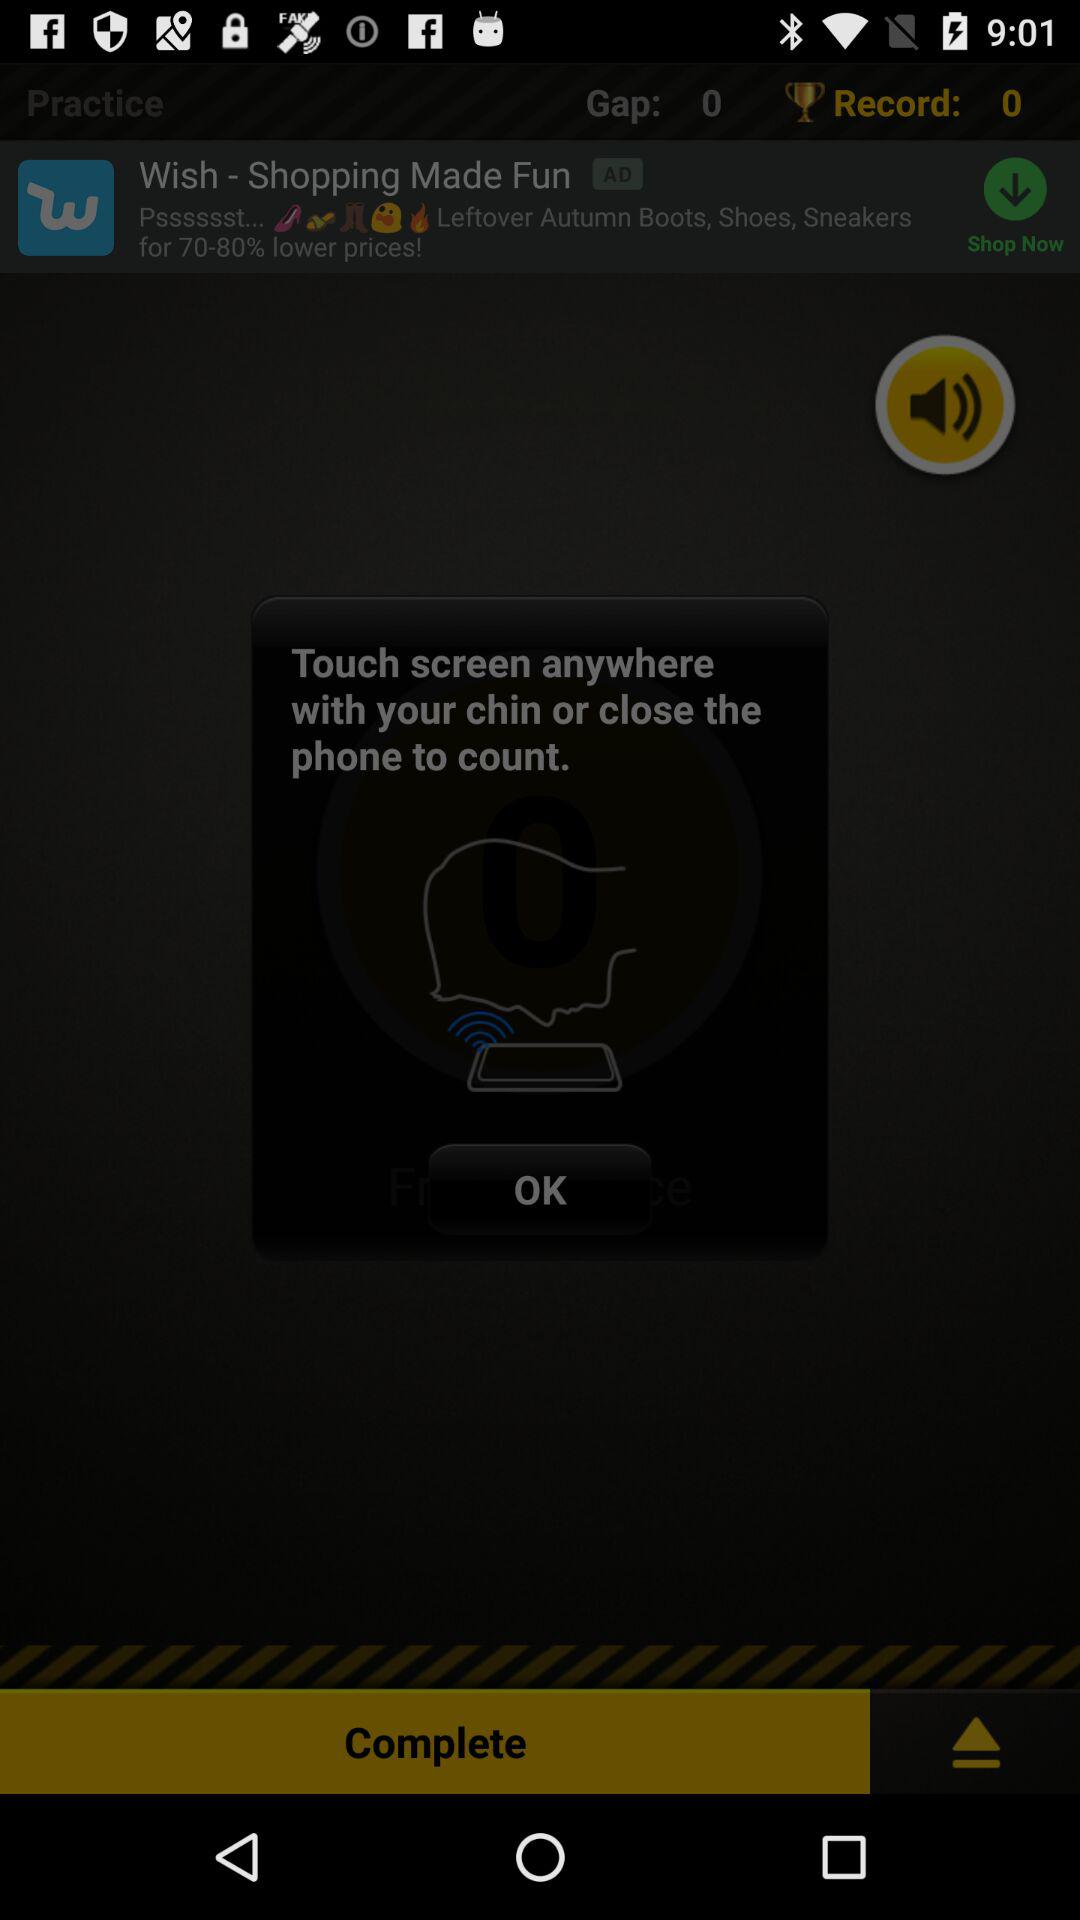What is the difference between the record and the gap?
Answer the question using a single word or phrase. 0 